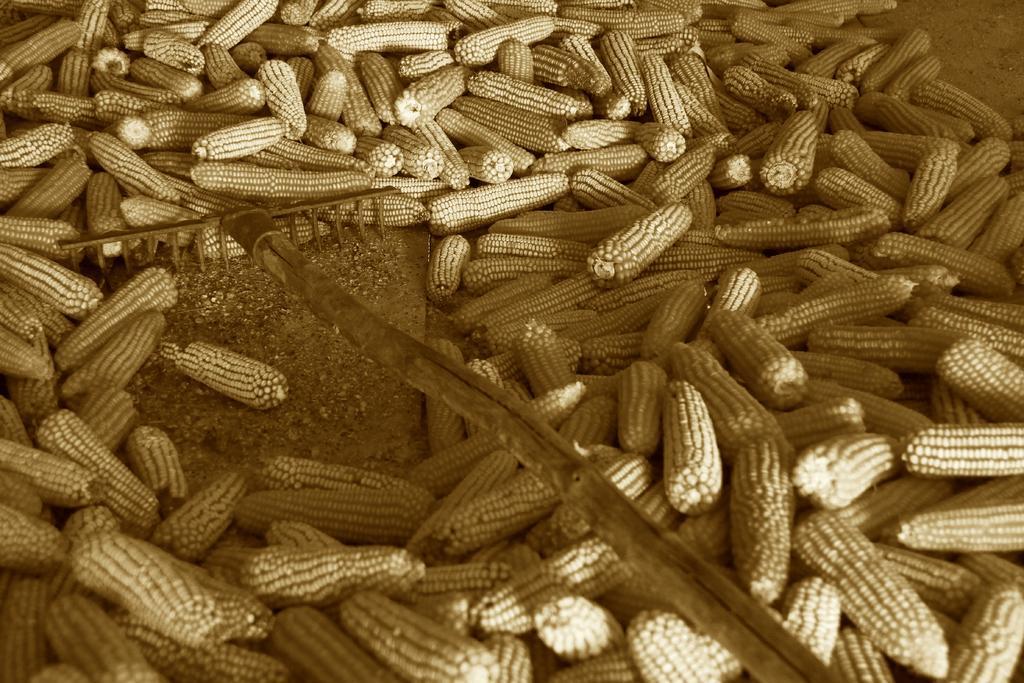Could you give a brief overview of what you see in this image? In this picture we can observe corn. There is a stick in this picture. We can observe a heap of corn. This is a black and white image. 